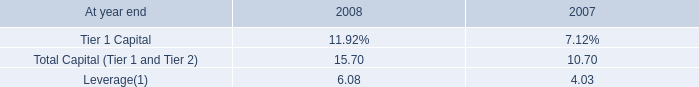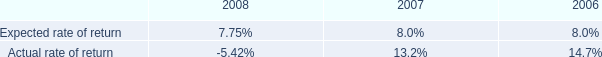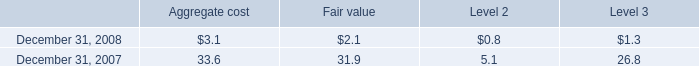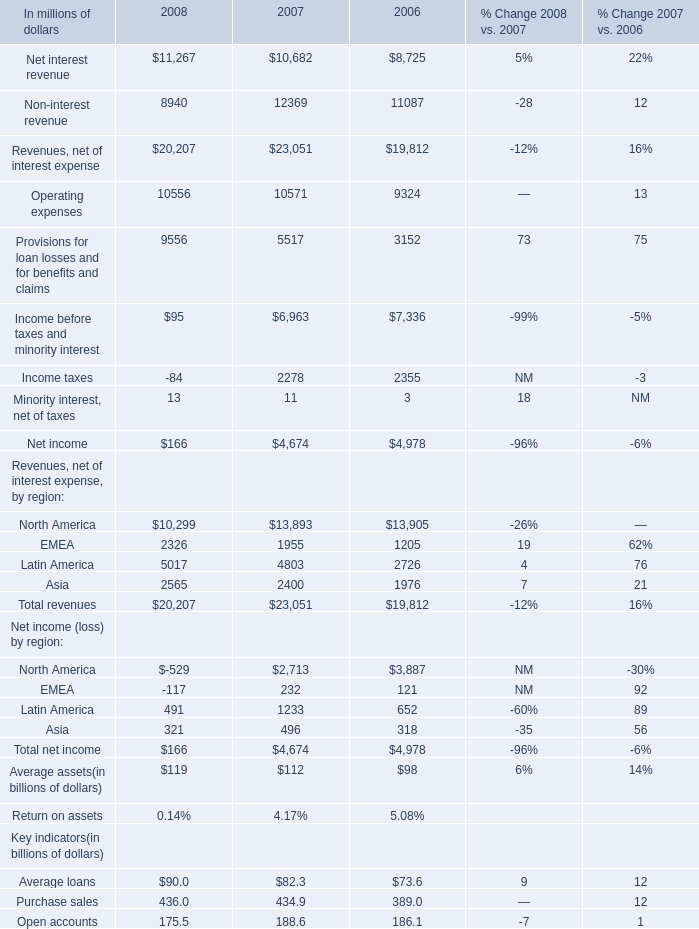Which year is Net income (loss) by region For EMEA the least? 
Answer: 2008. 